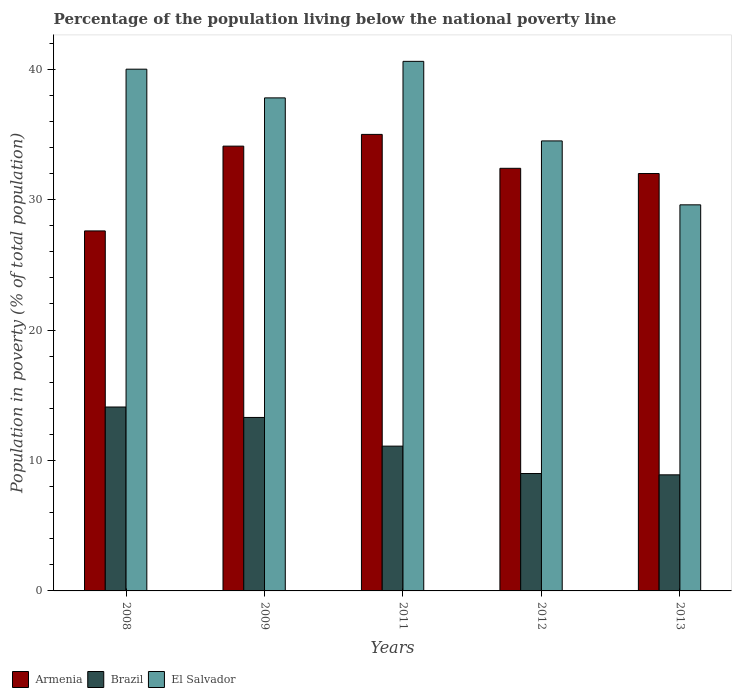How many groups of bars are there?
Keep it short and to the point. 5. How many bars are there on the 1st tick from the left?
Ensure brevity in your answer.  3. What is the percentage of the population living below the national poverty line in El Salvador in 2012?
Offer a terse response. 34.5. Across all years, what is the maximum percentage of the population living below the national poverty line in El Salvador?
Give a very brief answer. 40.6. Across all years, what is the minimum percentage of the population living below the national poverty line in El Salvador?
Your answer should be compact. 29.6. In which year was the percentage of the population living below the national poverty line in Brazil minimum?
Provide a succinct answer. 2013. What is the total percentage of the population living below the national poverty line in Armenia in the graph?
Provide a short and direct response. 161.1. What is the average percentage of the population living below the national poverty line in Brazil per year?
Keep it short and to the point. 11.28. In the year 2011, what is the difference between the percentage of the population living below the national poverty line in Armenia and percentage of the population living below the national poverty line in El Salvador?
Provide a short and direct response. -5.6. What is the ratio of the percentage of the population living below the national poverty line in Armenia in 2011 to that in 2012?
Provide a short and direct response. 1.08. What is the difference between the highest and the second highest percentage of the population living below the national poverty line in El Salvador?
Make the answer very short. 0.6. What is the difference between the highest and the lowest percentage of the population living below the national poverty line in El Salvador?
Keep it short and to the point. 11. Is the sum of the percentage of the population living below the national poverty line in Armenia in 2008 and 2011 greater than the maximum percentage of the population living below the national poverty line in El Salvador across all years?
Offer a very short reply. Yes. What does the 1st bar from the left in 2012 represents?
Your answer should be compact. Armenia. Are all the bars in the graph horizontal?
Give a very brief answer. No. What is the difference between two consecutive major ticks on the Y-axis?
Give a very brief answer. 10. Are the values on the major ticks of Y-axis written in scientific E-notation?
Give a very brief answer. No. How many legend labels are there?
Keep it short and to the point. 3. What is the title of the graph?
Make the answer very short. Percentage of the population living below the national poverty line. Does "Somalia" appear as one of the legend labels in the graph?
Your answer should be very brief. No. What is the label or title of the Y-axis?
Your response must be concise. Population in poverty (% of total population). What is the Population in poverty (% of total population) in Armenia in 2008?
Offer a terse response. 27.6. What is the Population in poverty (% of total population) of El Salvador in 2008?
Offer a very short reply. 40. What is the Population in poverty (% of total population) in Armenia in 2009?
Provide a succinct answer. 34.1. What is the Population in poverty (% of total population) of Brazil in 2009?
Keep it short and to the point. 13.3. What is the Population in poverty (% of total population) of El Salvador in 2009?
Provide a succinct answer. 37.8. What is the Population in poverty (% of total population) in El Salvador in 2011?
Your answer should be compact. 40.6. What is the Population in poverty (% of total population) in Armenia in 2012?
Offer a very short reply. 32.4. What is the Population in poverty (% of total population) of El Salvador in 2012?
Make the answer very short. 34.5. What is the Population in poverty (% of total population) in El Salvador in 2013?
Provide a succinct answer. 29.6. Across all years, what is the maximum Population in poverty (% of total population) in El Salvador?
Your answer should be very brief. 40.6. Across all years, what is the minimum Population in poverty (% of total population) in Armenia?
Give a very brief answer. 27.6. Across all years, what is the minimum Population in poverty (% of total population) in El Salvador?
Offer a very short reply. 29.6. What is the total Population in poverty (% of total population) in Armenia in the graph?
Provide a succinct answer. 161.1. What is the total Population in poverty (% of total population) in Brazil in the graph?
Provide a succinct answer. 56.4. What is the total Population in poverty (% of total population) in El Salvador in the graph?
Provide a succinct answer. 182.5. What is the difference between the Population in poverty (% of total population) in Armenia in 2008 and that in 2009?
Provide a succinct answer. -6.5. What is the difference between the Population in poverty (% of total population) in Armenia in 2008 and that in 2011?
Give a very brief answer. -7.4. What is the difference between the Population in poverty (% of total population) of El Salvador in 2008 and that in 2011?
Ensure brevity in your answer.  -0.6. What is the difference between the Population in poverty (% of total population) of Brazil in 2008 and that in 2012?
Your answer should be compact. 5.1. What is the difference between the Population in poverty (% of total population) in El Salvador in 2008 and that in 2012?
Your answer should be compact. 5.5. What is the difference between the Population in poverty (% of total population) in Brazil in 2008 and that in 2013?
Make the answer very short. 5.2. What is the difference between the Population in poverty (% of total population) in El Salvador in 2008 and that in 2013?
Provide a succinct answer. 10.4. What is the difference between the Population in poverty (% of total population) in Brazil in 2009 and that in 2011?
Your response must be concise. 2.2. What is the difference between the Population in poverty (% of total population) of El Salvador in 2009 and that in 2011?
Provide a succinct answer. -2.8. What is the difference between the Population in poverty (% of total population) of Armenia in 2009 and that in 2012?
Offer a very short reply. 1.7. What is the difference between the Population in poverty (% of total population) of Brazil in 2009 and that in 2012?
Your answer should be very brief. 4.3. What is the difference between the Population in poverty (% of total population) of El Salvador in 2009 and that in 2013?
Make the answer very short. 8.2. What is the difference between the Population in poverty (% of total population) of Armenia in 2011 and that in 2012?
Your response must be concise. 2.6. What is the difference between the Population in poverty (% of total population) of Brazil in 2011 and that in 2012?
Keep it short and to the point. 2.1. What is the difference between the Population in poverty (% of total population) in Brazil in 2011 and that in 2013?
Ensure brevity in your answer.  2.2. What is the difference between the Population in poverty (% of total population) in El Salvador in 2011 and that in 2013?
Make the answer very short. 11. What is the difference between the Population in poverty (% of total population) in Armenia in 2012 and that in 2013?
Provide a short and direct response. 0.4. What is the difference between the Population in poverty (% of total population) in Brazil in 2012 and that in 2013?
Offer a very short reply. 0.1. What is the difference between the Population in poverty (% of total population) in El Salvador in 2012 and that in 2013?
Offer a terse response. 4.9. What is the difference between the Population in poverty (% of total population) in Armenia in 2008 and the Population in poverty (% of total population) in Brazil in 2009?
Offer a very short reply. 14.3. What is the difference between the Population in poverty (% of total population) of Armenia in 2008 and the Population in poverty (% of total population) of El Salvador in 2009?
Your answer should be compact. -10.2. What is the difference between the Population in poverty (% of total population) of Brazil in 2008 and the Population in poverty (% of total population) of El Salvador in 2009?
Keep it short and to the point. -23.7. What is the difference between the Population in poverty (% of total population) in Armenia in 2008 and the Population in poverty (% of total population) in Brazil in 2011?
Provide a succinct answer. 16.5. What is the difference between the Population in poverty (% of total population) in Armenia in 2008 and the Population in poverty (% of total population) in El Salvador in 2011?
Keep it short and to the point. -13. What is the difference between the Population in poverty (% of total population) of Brazil in 2008 and the Population in poverty (% of total population) of El Salvador in 2011?
Provide a succinct answer. -26.5. What is the difference between the Population in poverty (% of total population) of Armenia in 2008 and the Population in poverty (% of total population) of El Salvador in 2012?
Provide a short and direct response. -6.9. What is the difference between the Population in poverty (% of total population) of Brazil in 2008 and the Population in poverty (% of total population) of El Salvador in 2012?
Offer a terse response. -20.4. What is the difference between the Population in poverty (% of total population) in Armenia in 2008 and the Population in poverty (% of total population) in Brazil in 2013?
Offer a terse response. 18.7. What is the difference between the Population in poverty (% of total population) in Armenia in 2008 and the Population in poverty (% of total population) in El Salvador in 2013?
Give a very brief answer. -2. What is the difference between the Population in poverty (% of total population) in Brazil in 2008 and the Population in poverty (% of total population) in El Salvador in 2013?
Your answer should be very brief. -15.5. What is the difference between the Population in poverty (% of total population) of Armenia in 2009 and the Population in poverty (% of total population) of El Salvador in 2011?
Provide a short and direct response. -6.5. What is the difference between the Population in poverty (% of total population) in Brazil in 2009 and the Population in poverty (% of total population) in El Salvador in 2011?
Give a very brief answer. -27.3. What is the difference between the Population in poverty (% of total population) of Armenia in 2009 and the Population in poverty (% of total population) of Brazil in 2012?
Keep it short and to the point. 25.1. What is the difference between the Population in poverty (% of total population) of Brazil in 2009 and the Population in poverty (% of total population) of El Salvador in 2012?
Provide a short and direct response. -21.2. What is the difference between the Population in poverty (% of total population) in Armenia in 2009 and the Population in poverty (% of total population) in Brazil in 2013?
Keep it short and to the point. 25.2. What is the difference between the Population in poverty (% of total population) of Brazil in 2009 and the Population in poverty (% of total population) of El Salvador in 2013?
Provide a succinct answer. -16.3. What is the difference between the Population in poverty (% of total population) in Brazil in 2011 and the Population in poverty (% of total population) in El Salvador in 2012?
Offer a very short reply. -23.4. What is the difference between the Population in poverty (% of total population) in Armenia in 2011 and the Population in poverty (% of total population) in Brazil in 2013?
Offer a very short reply. 26.1. What is the difference between the Population in poverty (% of total population) of Armenia in 2011 and the Population in poverty (% of total population) of El Salvador in 2013?
Offer a terse response. 5.4. What is the difference between the Population in poverty (% of total population) of Brazil in 2011 and the Population in poverty (% of total population) of El Salvador in 2013?
Your answer should be very brief. -18.5. What is the difference between the Population in poverty (% of total population) of Brazil in 2012 and the Population in poverty (% of total population) of El Salvador in 2013?
Provide a short and direct response. -20.6. What is the average Population in poverty (% of total population) in Armenia per year?
Keep it short and to the point. 32.22. What is the average Population in poverty (% of total population) in Brazil per year?
Make the answer very short. 11.28. What is the average Population in poverty (% of total population) of El Salvador per year?
Offer a terse response. 36.5. In the year 2008, what is the difference between the Population in poverty (% of total population) of Armenia and Population in poverty (% of total population) of Brazil?
Offer a very short reply. 13.5. In the year 2008, what is the difference between the Population in poverty (% of total population) in Armenia and Population in poverty (% of total population) in El Salvador?
Your response must be concise. -12.4. In the year 2008, what is the difference between the Population in poverty (% of total population) of Brazil and Population in poverty (% of total population) of El Salvador?
Give a very brief answer. -25.9. In the year 2009, what is the difference between the Population in poverty (% of total population) in Armenia and Population in poverty (% of total population) in Brazil?
Provide a short and direct response. 20.8. In the year 2009, what is the difference between the Population in poverty (% of total population) of Brazil and Population in poverty (% of total population) of El Salvador?
Offer a terse response. -24.5. In the year 2011, what is the difference between the Population in poverty (% of total population) of Armenia and Population in poverty (% of total population) of Brazil?
Your response must be concise. 23.9. In the year 2011, what is the difference between the Population in poverty (% of total population) of Armenia and Population in poverty (% of total population) of El Salvador?
Your response must be concise. -5.6. In the year 2011, what is the difference between the Population in poverty (% of total population) in Brazil and Population in poverty (% of total population) in El Salvador?
Keep it short and to the point. -29.5. In the year 2012, what is the difference between the Population in poverty (% of total population) of Armenia and Population in poverty (% of total population) of Brazil?
Your answer should be very brief. 23.4. In the year 2012, what is the difference between the Population in poverty (% of total population) of Armenia and Population in poverty (% of total population) of El Salvador?
Offer a terse response. -2.1. In the year 2012, what is the difference between the Population in poverty (% of total population) of Brazil and Population in poverty (% of total population) of El Salvador?
Offer a terse response. -25.5. In the year 2013, what is the difference between the Population in poverty (% of total population) in Armenia and Population in poverty (% of total population) in Brazil?
Give a very brief answer. 23.1. In the year 2013, what is the difference between the Population in poverty (% of total population) in Brazil and Population in poverty (% of total population) in El Salvador?
Give a very brief answer. -20.7. What is the ratio of the Population in poverty (% of total population) of Armenia in 2008 to that in 2009?
Provide a succinct answer. 0.81. What is the ratio of the Population in poverty (% of total population) of Brazil in 2008 to that in 2009?
Offer a very short reply. 1.06. What is the ratio of the Population in poverty (% of total population) in El Salvador in 2008 to that in 2009?
Offer a terse response. 1.06. What is the ratio of the Population in poverty (% of total population) in Armenia in 2008 to that in 2011?
Keep it short and to the point. 0.79. What is the ratio of the Population in poverty (% of total population) of Brazil in 2008 to that in 2011?
Provide a short and direct response. 1.27. What is the ratio of the Population in poverty (% of total population) of El Salvador in 2008 to that in 2011?
Keep it short and to the point. 0.99. What is the ratio of the Population in poverty (% of total population) of Armenia in 2008 to that in 2012?
Make the answer very short. 0.85. What is the ratio of the Population in poverty (% of total population) of Brazil in 2008 to that in 2012?
Your answer should be compact. 1.57. What is the ratio of the Population in poverty (% of total population) of El Salvador in 2008 to that in 2012?
Provide a short and direct response. 1.16. What is the ratio of the Population in poverty (% of total population) of Armenia in 2008 to that in 2013?
Provide a short and direct response. 0.86. What is the ratio of the Population in poverty (% of total population) of Brazil in 2008 to that in 2013?
Your answer should be very brief. 1.58. What is the ratio of the Population in poverty (% of total population) of El Salvador in 2008 to that in 2013?
Keep it short and to the point. 1.35. What is the ratio of the Population in poverty (% of total population) of Armenia in 2009 to that in 2011?
Your answer should be compact. 0.97. What is the ratio of the Population in poverty (% of total population) in Brazil in 2009 to that in 2011?
Offer a very short reply. 1.2. What is the ratio of the Population in poverty (% of total population) in Armenia in 2009 to that in 2012?
Give a very brief answer. 1.05. What is the ratio of the Population in poverty (% of total population) in Brazil in 2009 to that in 2012?
Your answer should be very brief. 1.48. What is the ratio of the Population in poverty (% of total population) in El Salvador in 2009 to that in 2012?
Give a very brief answer. 1.1. What is the ratio of the Population in poverty (% of total population) of Armenia in 2009 to that in 2013?
Give a very brief answer. 1.07. What is the ratio of the Population in poverty (% of total population) of Brazil in 2009 to that in 2013?
Provide a short and direct response. 1.49. What is the ratio of the Population in poverty (% of total population) of El Salvador in 2009 to that in 2013?
Ensure brevity in your answer.  1.28. What is the ratio of the Population in poverty (% of total population) of Armenia in 2011 to that in 2012?
Your answer should be very brief. 1.08. What is the ratio of the Population in poverty (% of total population) of Brazil in 2011 to that in 2012?
Provide a short and direct response. 1.23. What is the ratio of the Population in poverty (% of total population) in El Salvador in 2011 to that in 2012?
Ensure brevity in your answer.  1.18. What is the ratio of the Population in poverty (% of total population) in Armenia in 2011 to that in 2013?
Offer a terse response. 1.09. What is the ratio of the Population in poverty (% of total population) in Brazil in 2011 to that in 2013?
Your answer should be compact. 1.25. What is the ratio of the Population in poverty (% of total population) in El Salvador in 2011 to that in 2013?
Ensure brevity in your answer.  1.37. What is the ratio of the Population in poverty (% of total population) in Armenia in 2012 to that in 2013?
Make the answer very short. 1.01. What is the ratio of the Population in poverty (% of total population) in Brazil in 2012 to that in 2013?
Provide a short and direct response. 1.01. What is the ratio of the Population in poverty (% of total population) of El Salvador in 2012 to that in 2013?
Provide a short and direct response. 1.17. What is the difference between the highest and the second highest Population in poverty (% of total population) in Armenia?
Give a very brief answer. 0.9. What is the difference between the highest and the second highest Population in poverty (% of total population) in El Salvador?
Offer a very short reply. 0.6. What is the difference between the highest and the lowest Population in poverty (% of total population) of Brazil?
Provide a short and direct response. 5.2. 